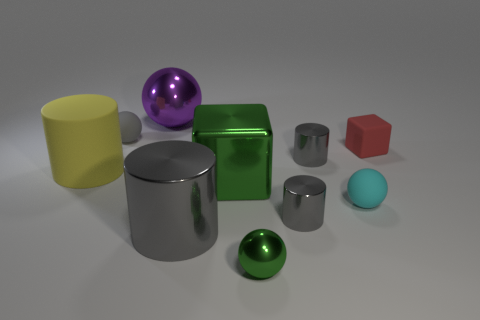Subtract all gray cylinders. How many were subtracted if there are2gray cylinders left? 1 Subtract all tiny cyan rubber balls. How many balls are left? 3 Subtract all cyan cubes. How many gray cylinders are left? 3 Subtract all yellow cylinders. How many cylinders are left? 3 Subtract all purple cylinders. Subtract all purple spheres. How many cylinders are left? 4 Subtract all balls. How many objects are left? 6 Add 2 large purple metal objects. How many large purple metal objects exist? 3 Subtract 0 blue cylinders. How many objects are left? 10 Subtract all small gray cylinders. Subtract all tiny gray matte things. How many objects are left? 7 Add 2 red objects. How many red objects are left? 3 